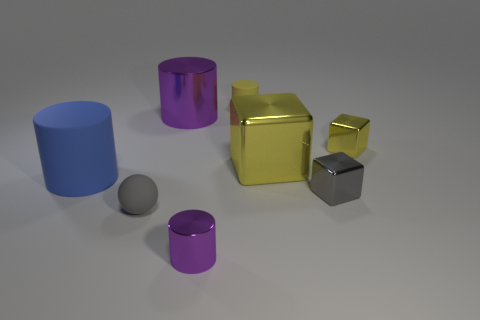There is a tiny purple thing; are there any blue things in front of it?
Offer a very short reply. No. What is the color of the small block in front of the large blue matte cylinder?
Your answer should be very brief. Gray. What is the material of the big thing to the right of the tiny rubber object that is to the right of the sphere?
Provide a short and direct response. Metal. Are there fewer tiny gray matte balls on the right side of the small yellow matte thing than tiny cubes on the right side of the large metallic cube?
Give a very brief answer. Yes. What number of cyan objects are rubber balls or large matte things?
Your response must be concise. 0. Are there an equal number of small purple cylinders in front of the yellow matte cylinder and yellow metal cubes?
Make the answer very short. No. What number of things are either blue cylinders or small things that are right of the big yellow shiny thing?
Provide a short and direct response. 3. Does the large cube have the same color as the small rubber sphere?
Keep it short and to the point. No. Is there a yellow ball made of the same material as the large blue object?
Ensure brevity in your answer.  No. The other rubber object that is the same shape as the large blue rubber thing is what color?
Provide a succinct answer. Yellow. 